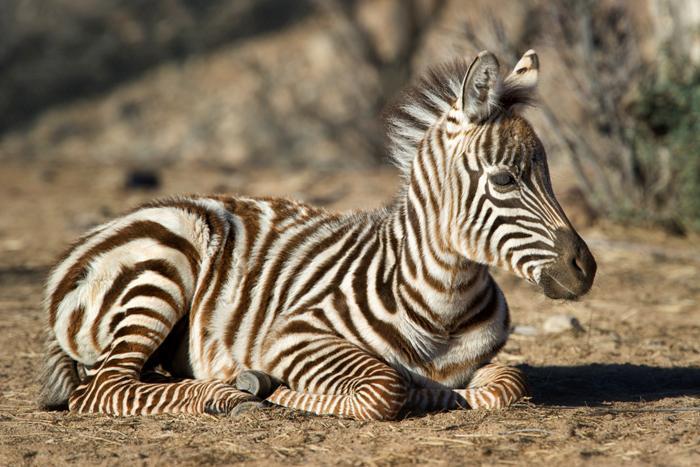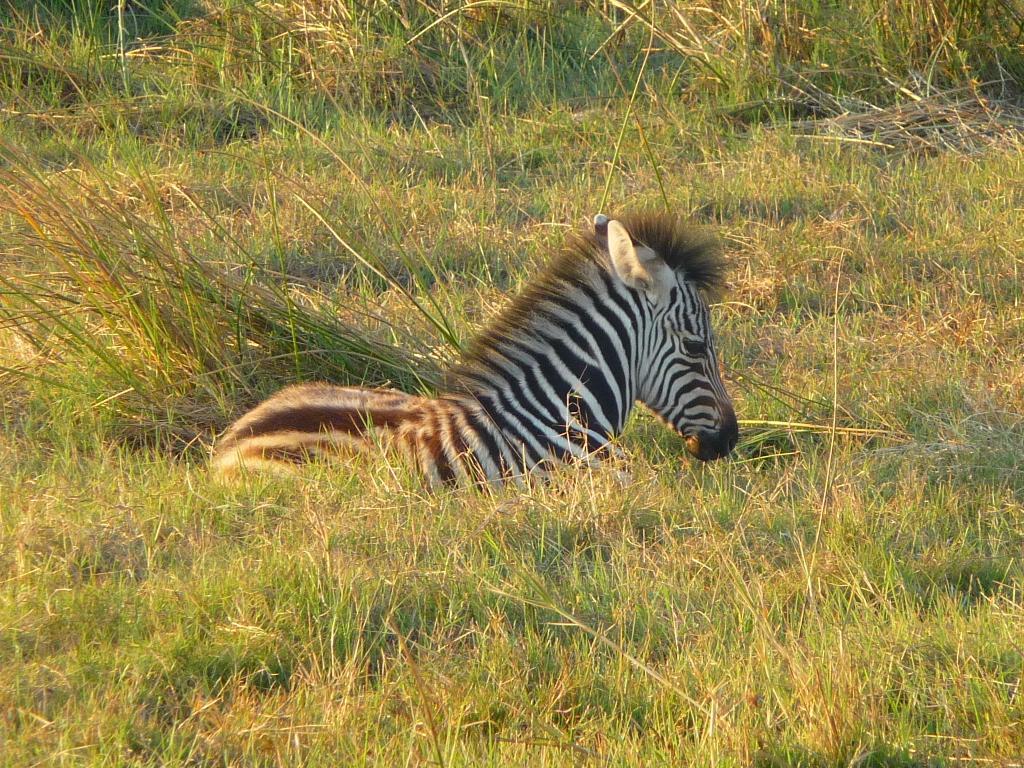The first image is the image on the left, the second image is the image on the right. Considering the images on both sides, is "Each image shows a zebra resting in the grass, and one image actually shows the zebra in a position with front knees both bent." valid? Answer yes or no. Yes. The first image is the image on the left, the second image is the image on the right. Analyze the images presented: Is the assertion "The zebra in the image on the left is standing in a field." valid? Answer yes or no. No. 